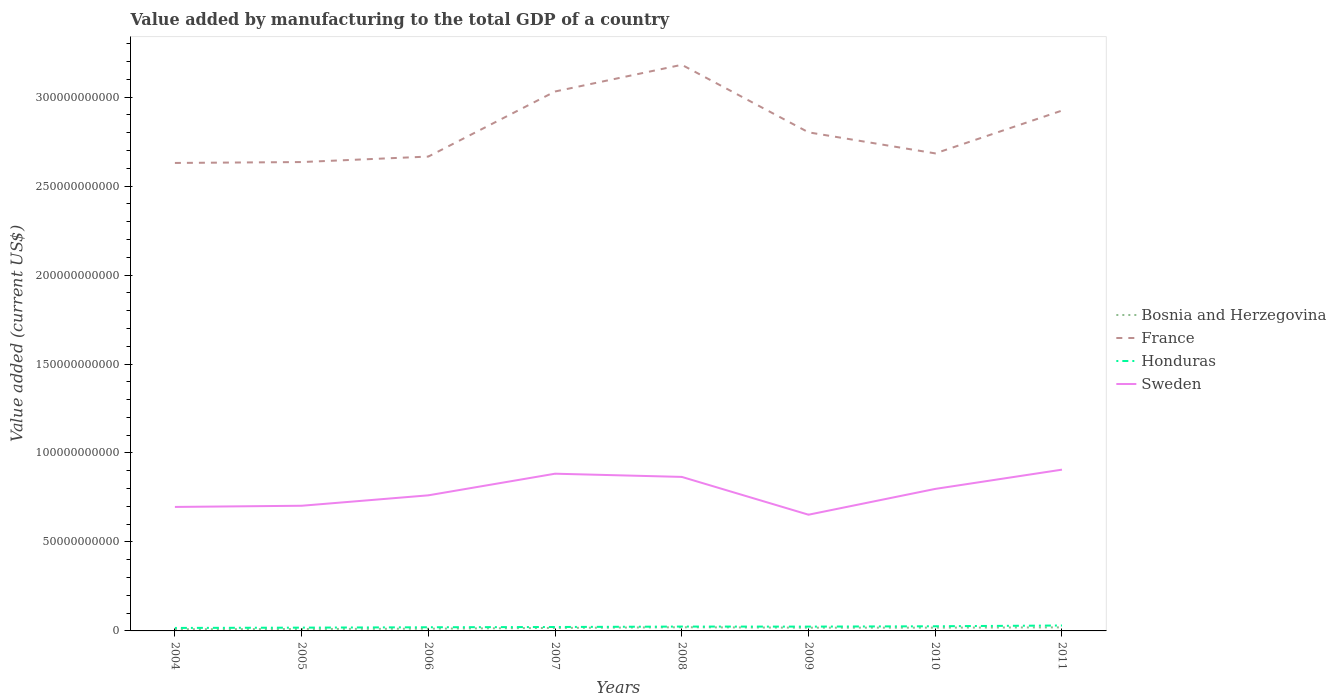How many different coloured lines are there?
Offer a terse response. 4. Does the line corresponding to Sweden intersect with the line corresponding to Honduras?
Your response must be concise. No. Across all years, what is the maximum value added by manufacturing to the total GDP in Honduras?
Make the answer very short. 1.68e+09. In which year was the value added by manufacturing to the total GDP in Honduras maximum?
Your answer should be very brief. 2004. What is the total value added by manufacturing to the total GDP in Bosnia and Herzegovina in the graph?
Provide a short and direct response. -1.40e+08. What is the difference between the highest and the second highest value added by manufacturing to the total GDP in Sweden?
Your answer should be compact. 2.53e+1. What is the difference between the highest and the lowest value added by manufacturing to the total GDP in Bosnia and Herzegovina?
Keep it short and to the point. 5. Is the value added by manufacturing to the total GDP in Bosnia and Herzegovina strictly greater than the value added by manufacturing to the total GDP in France over the years?
Make the answer very short. Yes. How many lines are there?
Make the answer very short. 4. How many years are there in the graph?
Offer a very short reply. 8. What is the difference between two consecutive major ticks on the Y-axis?
Your answer should be very brief. 5.00e+1. Does the graph contain any zero values?
Provide a succinct answer. No. Does the graph contain grids?
Your answer should be compact. No. Where does the legend appear in the graph?
Keep it short and to the point. Center right. How are the legend labels stacked?
Your answer should be compact. Vertical. What is the title of the graph?
Make the answer very short. Value added by manufacturing to the total GDP of a country. Does "Russian Federation" appear as one of the legend labels in the graph?
Offer a very short reply. No. What is the label or title of the Y-axis?
Provide a succinct answer. Value added (current US$). What is the Value added (current US$) of Bosnia and Herzegovina in 2004?
Make the answer very short. 9.40e+08. What is the Value added (current US$) of France in 2004?
Provide a succinct answer. 2.63e+11. What is the Value added (current US$) in Honduras in 2004?
Give a very brief answer. 1.68e+09. What is the Value added (current US$) of Sweden in 2004?
Offer a very short reply. 6.97e+1. What is the Value added (current US$) in Bosnia and Herzegovina in 2005?
Give a very brief answer. 1.08e+09. What is the Value added (current US$) in France in 2005?
Keep it short and to the point. 2.64e+11. What is the Value added (current US$) of Honduras in 2005?
Keep it short and to the point. 1.85e+09. What is the Value added (current US$) of Sweden in 2005?
Your answer should be very brief. 7.03e+1. What is the Value added (current US$) of Bosnia and Herzegovina in 2006?
Your response must be concise. 1.25e+09. What is the Value added (current US$) of France in 2006?
Ensure brevity in your answer.  2.67e+11. What is the Value added (current US$) of Honduras in 2006?
Provide a succinct answer. 2.06e+09. What is the Value added (current US$) of Sweden in 2006?
Your response must be concise. 7.62e+1. What is the Value added (current US$) in Bosnia and Herzegovina in 2007?
Keep it short and to the point. 1.68e+09. What is the Value added (current US$) of France in 2007?
Your response must be concise. 3.03e+11. What is the Value added (current US$) in Honduras in 2007?
Offer a very short reply. 2.20e+09. What is the Value added (current US$) of Sweden in 2007?
Give a very brief answer. 8.84e+1. What is the Value added (current US$) of Bosnia and Herzegovina in 2008?
Make the answer very short. 2.07e+09. What is the Value added (current US$) of France in 2008?
Make the answer very short. 3.18e+11. What is the Value added (current US$) of Honduras in 2008?
Make the answer very short. 2.46e+09. What is the Value added (current US$) in Sweden in 2008?
Offer a very short reply. 8.66e+1. What is the Value added (current US$) of Bosnia and Herzegovina in 2009?
Your answer should be very brief. 1.81e+09. What is the Value added (current US$) of France in 2009?
Offer a terse response. 2.80e+11. What is the Value added (current US$) in Honduras in 2009?
Offer a very short reply. 2.43e+09. What is the Value added (current US$) in Sweden in 2009?
Provide a succinct answer. 6.53e+1. What is the Value added (current US$) of Bosnia and Herzegovina in 2010?
Offer a very short reply. 1.83e+09. What is the Value added (current US$) in France in 2010?
Offer a very short reply. 2.68e+11. What is the Value added (current US$) in Honduras in 2010?
Provide a short and direct response. 2.62e+09. What is the Value added (current US$) of Sweden in 2010?
Keep it short and to the point. 7.98e+1. What is the Value added (current US$) in Bosnia and Herzegovina in 2011?
Your response must be concise. 2.00e+09. What is the Value added (current US$) of France in 2011?
Your answer should be very brief. 2.92e+11. What is the Value added (current US$) in Honduras in 2011?
Provide a succinct answer. 3.05e+09. What is the Value added (current US$) in Sweden in 2011?
Provide a succinct answer. 9.06e+1. Across all years, what is the maximum Value added (current US$) of Bosnia and Herzegovina?
Provide a short and direct response. 2.07e+09. Across all years, what is the maximum Value added (current US$) in France?
Keep it short and to the point. 3.18e+11. Across all years, what is the maximum Value added (current US$) in Honduras?
Give a very brief answer. 3.05e+09. Across all years, what is the maximum Value added (current US$) of Sweden?
Your answer should be compact. 9.06e+1. Across all years, what is the minimum Value added (current US$) of Bosnia and Herzegovina?
Keep it short and to the point. 9.40e+08. Across all years, what is the minimum Value added (current US$) in France?
Offer a very short reply. 2.63e+11. Across all years, what is the minimum Value added (current US$) of Honduras?
Offer a terse response. 1.68e+09. Across all years, what is the minimum Value added (current US$) of Sweden?
Provide a succinct answer. 6.53e+1. What is the total Value added (current US$) of Bosnia and Herzegovina in the graph?
Keep it short and to the point. 1.27e+1. What is the total Value added (current US$) in France in the graph?
Your answer should be very brief. 2.26e+12. What is the total Value added (current US$) of Honduras in the graph?
Keep it short and to the point. 1.83e+1. What is the total Value added (current US$) of Sweden in the graph?
Offer a terse response. 6.27e+11. What is the difference between the Value added (current US$) of Bosnia and Herzegovina in 2004 and that in 2005?
Your answer should be compact. -1.40e+08. What is the difference between the Value added (current US$) of France in 2004 and that in 2005?
Your response must be concise. -5.05e+08. What is the difference between the Value added (current US$) in Honduras in 2004 and that in 2005?
Ensure brevity in your answer.  -1.65e+08. What is the difference between the Value added (current US$) in Sweden in 2004 and that in 2005?
Make the answer very short. -6.65e+08. What is the difference between the Value added (current US$) of Bosnia and Herzegovina in 2004 and that in 2006?
Provide a succinct answer. -3.15e+08. What is the difference between the Value added (current US$) in France in 2004 and that in 2006?
Your response must be concise. -3.59e+09. What is the difference between the Value added (current US$) in Honduras in 2004 and that in 2006?
Provide a short and direct response. -3.76e+08. What is the difference between the Value added (current US$) of Sweden in 2004 and that in 2006?
Your response must be concise. -6.53e+09. What is the difference between the Value added (current US$) of Bosnia and Herzegovina in 2004 and that in 2007?
Ensure brevity in your answer.  -7.42e+08. What is the difference between the Value added (current US$) of France in 2004 and that in 2007?
Your answer should be very brief. -4.02e+1. What is the difference between the Value added (current US$) in Honduras in 2004 and that in 2007?
Provide a succinct answer. -5.23e+08. What is the difference between the Value added (current US$) in Sweden in 2004 and that in 2007?
Give a very brief answer. -1.87e+1. What is the difference between the Value added (current US$) in Bosnia and Herzegovina in 2004 and that in 2008?
Provide a succinct answer. -1.13e+09. What is the difference between the Value added (current US$) in France in 2004 and that in 2008?
Make the answer very short. -5.52e+1. What is the difference between the Value added (current US$) in Honduras in 2004 and that in 2008?
Your response must be concise. -7.75e+08. What is the difference between the Value added (current US$) of Sweden in 2004 and that in 2008?
Provide a succinct answer. -1.69e+1. What is the difference between the Value added (current US$) of Bosnia and Herzegovina in 2004 and that in 2009?
Ensure brevity in your answer.  -8.75e+08. What is the difference between the Value added (current US$) in France in 2004 and that in 2009?
Keep it short and to the point. -1.72e+1. What is the difference between the Value added (current US$) of Honduras in 2004 and that in 2009?
Offer a very short reply. -7.45e+08. What is the difference between the Value added (current US$) of Sweden in 2004 and that in 2009?
Provide a succinct answer. 4.37e+09. What is the difference between the Value added (current US$) in Bosnia and Herzegovina in 2004 and that in 2010?
Provide a succinct answer. -8.93e+08. What is the difference between the Value added (current US$) of France in 2004 and that in 2010?
Offer a very short reply. -5.37e+09. What is the difference between the Value added (current US$) of Honduras in 2004 and that in 2010?
Provide a short and direct response. -9.39e+08. What is the difference between the Value added (current US$) of Sweden in 2004 and that in 2010?
Keep it short and to the point. -1.01e+1. What is the difference between the Value added (current US$) in Bosnia and Herzegovina in 2004 and that in 2011?
Your answer should be compact. -1.06e+09. What is the difference between the Value added (current US$) in France in 2004 and that in 2011?
Offer a very short reply. -2.94e+1. What is the difference between the Value added (current US$) of Honduras in 2004 and that in 2011?
Your answer should be very brief. -1.36e+09. What is the difference between the Value added (current US$) of Sweden in 2004 and that in 2011?
Offer a terse response. -2.10e+1. What is the difference between the Value added (current US$) of Bosnia and Herzegovina in 2005 and that in 2006?
Your answer should be very brief. -1.75e+08. What is the difference between the Value added (current US$) in France in 2005 and that in 2006?
Ensure brevity in your answer.  -3.08e+09. What is the difference between the Value added (current US$) of Honduras in 2005 and that in 2006?
Keep it short and to the point. -2.11e+08. What is the difference between the Value added (current US$) of Sweden in 2005 and that in 2006?
Ensure brevity in your answer.  -5.86e+09. What is the difference between the Value added (current US$) of Bosnia and Herzegovina in 2005 and that in 2007?
Provide a short and direct response. -6.03e+08. What is the difference between the Value added (current US$) of France in 2005 and that in 2007?
Ensure brevity in your answer.  -3.97e+1. What is the difference between the Value added (current US$) of Honduras in 2005 and that in 2007?
Provide a short and direct response. -3.58e+08. What is the difference between the Value added (current US$) in Sweden in 2005 and that in 2007?
Make the answer very short. -1.80e+1. What is the difference between the Value added (current US$) of Bosnia and Herzegovina in 2005 and that in 2008?
Make the answer very short. -9.92e+08. What is the difference between the Value added (current US$) in France in 2005 and that in 2008?
Your answer should be compact. -5.47e+1. What is the difference between the Value added (current US$) in Honduras in 2005 and that in 2008?
Provide a succinct answer. -6.09e+08. What is the difference between the Value added (current US$) of Sweden in 2005 and that in 2008?
Provide a succinct answer. -1.62e+1. What is the difference between the Value added (current US$) in Bosnia and Herzegovina in 2005 and that in 2009?
Offer a very short reply. -7.35e+08. What is the difference between the Value added (current US$) in France in 2005 and that in 2009?
Provide a short and direct response. -1.67e+1. What is the difference between the Value added (current US$) in Honduras in 2005 and that in 2009?
Keep it short and to the point. -5.80e+08. What is the difference between the Value added (current US$) of Sweden in 2005 and that in 2009?
Make the answer very short. 5.03e+09. What is the difference between the Value added (current US$) of Bosnia and Herzegovina in 2005 and that in 2010?
Offer a very short reply. -7.53e+08. What is the difference between the Value added (current US$) in France in 2005 and that in 2010?
Offer a terse response. -4.87e+09. What is the difference between the Value added (current US$) of Honduras in 2005 and that in 2010?
Keep it short and to the point. -7.73e+08. What is the difference between the Value added (current US$) of Sweden in 2005 and that in 2010?
Provide a short and direct response. -9.47e+09. What is the difference between the Value added (current US$) in Bosnia and Herzegovina in 2005 and that in 2011?
Make the answer very short. -9.18e+08. What is the difference between the Value added (current US$) of France in 2005 and that in 2011?
Give a very brief answer. -2.89e+1. What is the difference between the Value added (current US$) of Honduras in 2005 and that in 2011?
Offer a very short reply. -1.20e+09. What is the difference between the Value added (current US$) in Sweden in 2005 and that in 2011?
Give a very brief answer. -2.03e+1. What is the difference between the Value added (current US$) in Bosnia and Herzegovina in 2006 and that in 2007?
Ensure brevity in your answer.  -4.27e+08. What is the difference between the Value added (current US$) of France in 2006 and that in 2007?
Keep it short and to the point. -3.66e+1. What is the difference between the Value added (current US$) of Honduras in 2006 and that in 2007?
Provide a short and direct response. -1.47e+08. What is the difference between the Value added (current US$) in Sweden in 2006 and that in 2007?
Give a very brief answer. -1.22e+1. What is the difference between the Value added (current US$) of Bosnia and Herzegovina in 2006 and that in 2008?
Give a very brief answer. -8.16e+08. What is the difference between the Value added (current US$) in France in 2006 and that in 2008?
Provide a succinct answer. -5.16e+1. What is the difference between the Value added (current US$) in Honduras in 2006 and that in 2008?
Your answer should be compact. -3.99e+08. What is the difference between the Value added (current US$) of Sweden in 2006 and that in 2008?
Provide a short and direct response. -1.04e+1. What is the difference between the Value added (current US$) in Bosnia and Herzegovina in 2006 and that in 2009?
Offer a terse response. -5.60e+08. What is the difference between the Value added (current US$) in France in 2006 and that in 2009?
Make the answer very short. -1.36e+1. What is the difference between the Value added (current US$) in Honduras in 2006 and that in 2009?
Your response must be concise. -3.69e+08. What is the difference between the Value added (current US$) of Sweden in 2006 and that in 2009?
Provide a short and direct response. 1.09e+1. What is the difference between the Value added (current US$) of Bosnia and Herzegovina in 2006 and that in 2010?
Offer a very short reply. -5.78e+08. What is the difference between the Value added (current US$) in France in 2006 and that in 2010?
Give a very brief answer. -1.79e+09. What is the difference between the Value added (current US$) of Honduras in 2006 and that in 2010?
Your response must be concise. -5.63e+08. What is the difference between the Value added (current US$) of Sweden in 2006 and that in 2010?
Offer a very short reply. -3.61e+09. What is the difference between the Value added (current US$) of Bosnia and Herzegovina in 2006 and that in 2011?
Keep it short and to the point. -7.43e+08. What is the difference between the Value added (current US$) in France in 2006 and that in 2011?
Your response must be concise. -2.59e+1. What is the difference between the Value added (current US$) of Honduras in 2006 and that in 2011?
Your answer should be compact. -9.88e+08. What is the difference between the Value added (current US$) in Sweden in 2006 and that in 2011?
Ensure brevity in your answer.  -1.44e+1. What is the difference between the Value added (current US$) of Bosnia and Herzegovina in 2007 and that in 2008?
Offer a very short reply. -3.89e+08. What is the difference between the Value added (current US$) in France in 2007 and that in 2008?
Provide a short and direct response. -1.50e+1. What is the difference between the Value added (current US$) in Honduras in 2007 and that in 2008?
Ensure brevity in your answer.  -2.52e+08. What is the difference between the Value added (current US$) in Sweden in 2007 and that in 2008?
Provide a succinct answer. 1.80e+09. What is the difference between the Value added (current US$) of Bosnia and Herzegovina in 2007 and that in 2009?
Keep it short and to the point. -1.33e+08. What is the difference between the Value added (current US$) of France in 2007 and that in 2009?
Provide a short and direct response. 2.30e+1. What is the difference between the Value added (current US$) of Honduras in 2007 and that in 2009?
Make the answer very short. -2.22e+08. What is the difference between the Value added (current US$) of Sweden in 2007 and that in 2009?
Give a very brief answer. 2.30e+1. What is the difference between the Value added (current US$) of Bosnia and Herzegovina in 2007 and that in 2010?
Make the answer very short. -1.50e+08. What is the difference between the Value added (current US$) in France in 2007 and that in 2010?
Your answer should be very brief. 3.48e+1. What is the difference between the Value added (current US$) of Honduras in 2007 and that in 2010?
Give a very brief answer. -4.16e+08. What is the difference between the Value added (current US$) of Sweden in 2007 and that in 2010?
Your response must be concise. 8.54e+09. What is the difference between the Value added (current US$) in Bosnia and Herzegovina in 2007 and that in 2011?
Make the answer very short. -3.15e+08. What is the difference between the Value added (current US$) of France in 2007 and that in 2011?
Your answer should be compact. 1.07e+1. What is the difference between the Value added (current US$) in Honduras in 2007 and that in 2011?
Provide a succinct answer. -8.42e+08. What is the difference between the Value added (current US$) of Sweden in 2007 and that in 2011?
Offer a very short reply. -2.28e+09. What is the difference between the Value added (current US$) of Bosnia and Herzegovina in 2008 and that in 2009?
Your answer should be compact. 2.56e+08. What is the difference between the Value added (current US$) in France in 2008 and that in 2009?
Your answer should be compact. 3.80e+1. What is the difference between the Value added (current US$) in Honduras in 2008 and that in 2009?
Provide a short and direct response. 2.93e+07. What is the difference between the Value added (current US$) of Sweden in 2008 and that in 2009?
Your response must be concise. 2.12e+1. What is the difference between the Value added (current US$) of Bosnia and Herzegovina in 2008 and that in 2010?
Give a very brief answer. 2.39e+08. What is the difference between the Value added (current US$) of France in 2008 and that in 2010?
Make the answer very short. 4.98e+1. What is the difference between the Value added (current US$) of Honduras in 2008 and that in 2010?
Give a very brief answer. -1.64e+08. What is the difference between the Value added (current US$) of Sweden in 2008 and that in 2010?
Your answer should be very brief. 6.74e+09. What is the difference between the Value added (current US$) in Bosnia and Herzegovina in 2008 and that in 2011?
Your response must be concise. 7.37e+07. What is the difference between the Value added (current US$) of France in 2008 and that in 2011?
Provide a short and direct response. 2.57e+1. What is the difference between the Value added (current US$) in Honduras in 2008 and that in 2011?
Provide a succinct answer. -5.90e+08. What is the difference between the Value added (current US$) of Sweden in 2008 and that in 2011?
Give a very brief answer. -4.08e+09. What is the difference between the Value added (current US$) in Bosnia and Herzegovina in 2009 and that in 2010?
Ensure brevity in your answer.  -1.75e+07. What is the difference between the Value added (current US$) of France in 2009 and that in 2010?
Provide a succinct answer. 1.18e+1. What is the difference between the Value added (current US$) of Honduras in 2009 and that in 2010?
Offer a very short reply. -1.93e+08. What is the difference between the Value added (current US$) of Sweden in 2009 and that in 2010?
Your answer should be very brief. -1.45e+1. What is the difference between the Value added (current US$) of Bosnia and Herzegovina in 2009 and that in 2011?
Your answer should be compact. -1.83e+08. What is the difference between the Value added (current US$) of France in 2009 and that in 2011?
Provide a short and direct response. -1.22e+1. What is the difference between the Value added (current US$) in Honduras in 2009 and that in 2011?
Provide a short and direct response. -6.19e+08. What is the difference between the Value added (current US$) of Sweden in 2009 and that in 2011?
Offer a very short reply. -2.53e+1. What is the difference between the Value added (current US$) in Bosnia and Herzegovina in 2010 and that in 2011?
Provide a short and direct response. -1.65e+08. What is the difference between the Value added (current US$) in France in 2010 and that in 2011?
Offer a terse response. -2.41e+1. What is the difference between the Value added (current US$) of Honduras in 2010 and that in 2011?
Offer a very short reply. -4.26e+08. What is the difference between the Value added (current US$) of Sweden in 2010 and that in 2011?
Your response must be concise. -1.08e+1. What is the difference between the Value added (current US$) of Bosnia and Herzegovina in 2004 and the Value added (current US$) of France in 2005?
Give a very brief answer. -2.63e+11. What is the difference between the Value added (current US$) of Bosnia and Herzegovina in 2004 and the Value added (current US$) of Honduras in 2005?
Offer a terse response. -9.06e+08. What is the difference between the Value added (current US$) of Bosnia and Herzegovina in 2004 and the Value added (current US$) of Sweden in 2005?
Your response must be concise. -6.94e+1. What is the difference between the Value added (current US$) of France in 2004 and the Value added (current US$) of Honduras in 2005?
Ensure brevity in your answer.  2.61e+11. What is the difference between the Value added (current US$) in France in 2004 and the Value added (current US$) in Sweden in 2005?
Give a very brief answer. 1.93e+11. What is the difference between the Value added (current US$) in Honduras in 2004 and the Value added (current US$) in Sweden in 2005?
Provide a succinct answer. -6.87e+1. What is the difference between the Value added (current US$) in Bosnia and Herzegovina in 2004 and the Value added (current US$) in France in 2006?
Give a very brief answer. -2.66e+11. What is the difference between the Value added (current US$) of Bosnia and Herzegovina in 2004 and the Value added (current US$) of Honduras in 2006?
Ensure brevity in your answer.  -1.12e+09. What is the difference between the Value added (current US$) in Bosnia and Herzegovina in 2004 and the Value added (current US$) in Sweden in 2006?
Your answer should be very brief. -7.53e+1. What is the difference between the Value added (current US$) of France in 2004 and the Value added (current US$) of Honduras in 2006?
Offer a very short reply. 2.61e+11. What is the difference between the Value added (current US$) of France in 2004 and the Value added (current US$) of Sweden in 2006?
Give a very brief answer. 1.87e+11. What is the difference between the Value added (current US$) of Honduras in 2004 and the Value added (current US$) of Sweden in 2006?
Your response must be concise. -7.45e+1. What is the difference between the Value added (current US$) in Bosnia and Herzegovina in 2004 and the Value added (current US$) in France in 2007?
Give a very brief answer. -3.02e+11. What is the difference between the Value added (current US$) of Bosnia and Herzegovina in 2004 and the Value added (current US$) of Honduras in 2007?
Provide a short and direct response. -1.26e+09. What is the difference between the Value added (current US$) of Bosnia and Herzegovina in 2004 and the Value added (current US$) of Sweden in 2007?
Your answer should be very brief. -8.74e+1. What is the difference between the Value added (current US$) of France in 2004 and the Value added (current US$) of Honduras in 2007?
Your response must be concise. 2.61e+11. What is the difference between the Value added (current US$) of France in 2004 and the Value added (current US$) of Sweden in 2007?
Offer a very short reply. 1.75e+11. What is the difference between the Value added (current US$) of Honduras in 2004 and the Value added (current US$) of Sweden in 2007?
Give a very brief answer. -8.67e+1. What is the difference between the Value added (current US$) in Bosnia and Herzegovina in 2004 and the Value added (current US$) in France in 2008?
Keep it short and to the point. -3.17e+11. What is the difference between the Value added (current US$) of Bosnia and Herzegovina in 2004 and the Value added (current US$) of Honduras in 2008?
Make the answer very short. -1.52e+09. What is the difference between the Value added (current US$) of Bosnia and Herzegovina in 2004 and the Value added (current US$) of Sweden in 2008?
Offer a terse response. -8.56e+1. What is the difference between the Value added (current US$) of France in 2004 and the Value added (current US$) of Honduras in 2008?
Keep it short and to the point. 2.61e+11. What is the difference between the Value added (current US$) in France in 2004 and the Value added (current US$) in Sweden in 2008?
Give a very brief answer. 1.76e+11. What is the difference between the Value added (current US$) of Honduras in 2004 and the Value added (current US$) of Sweden in 2008?
Provide a succinct answer. -8.49e+1. What is the difference between the Value added (current US$) in Bosnia and Herzegovina in 2004 and the Value added (current US$) in France in 2009?
Ensure brevity in your answer.  -2.79e+11. What is the difference between the Value added (current US$) in Bosnia and Herzegovina in 2004 and the Value added (current US$) in Honduras in 2009?
Provide a short and direct response. -1.49e+09. What is the difference between the Value added (current US$) of Bosnia and Herzegovina in 2004 and the Value added (current US$) of Sweden in 2009?
Your response must be concise. -6.44e+1. What is the difference between the Value added (current US$) in France in 2004 and the Value added (current US$) in Honduras in 2009?
Your answer should be compact. 2.61e+11. What is the difference between the Value added (current US$) in France in 2004 and the Value added (current US$) in Sweden in 2009?
Provide a short and direct response. 1.98e+11. What is the difference between the Value added (current US$) in Honduras in 2004 and the Value added (current US$) in Sweden in 2009?
Your response must be concise. -6.36e+1. What is the difference between the Value added (current US$) of Bosnia and Herzegovina in 2004 and the Value added (current US$) of France in 2010?
Your answer should be compact. -2.67e+11. What is the difference between the Value added (current US$) of Bosnia and Herzegovina in 2004 and the Value added (current US$) of Honduras in 2010?
Ensure brevity in your answer.  -1.68e+09. What is the difference between the Value added (current US$) in Bosnia and Herzegovina in 2004 and the Value added (current US$) in Sweden in 2010?
Offer a terse response. -7.89e+1. What is the difference between the Value added (current US$) in France in 2004 and the Value added (current US$) in Honduras in 2010?
Your answer should be compact. 2.60e+11. What is the difference between the Value added (current US$) in France in 2004 and the Value added (current US$) in Sweden in 2010?
Make the answer very short. 1.83e+11. What is the difference between the Value added (current US$) in Honduras in 2004 and the Value added (current US$) in Sweden in 2010?
Your answer should be very brief. -7.81e+1. What is the difference between the Value added (current US$) in Bosnia and Herzegovina in 2004 and the Value added (current US$) in France in 2011?
Keep it short and to the point. -2.91e+11. What is the difference between the Value added (current US$) of Bosnia and Herzegovina in 2004 and the Value added (current US$) of Honduras in 2011?
Provide a short and direct response. -2.11e+09. What is the difference between the Value added (current US$) in Bosnia and Herzegovina in 2004 and the Value added (current US$) in Sweden in 2011?
Provide a succinct answer. -8.97e+1. What is the difference between the Value added (current US$) in France in 2004 and the Value added (current US$) in Honduras in 2011?
Your answer should be very brief. 2.60e+11. What is the difference between the Value added (current US$) in France in 2004 and the Value added (current US$) in Sweden in 2011?
Provide a short and direct response. 1.72e+11. What is the difference between the Value added (current US$) in Honduras in 2004 and the Value added (current US$) in Sweden in 2011?
Your answer should be compact. -8.90e+1. What is the difference between the Value added (current US$) of Bosnia and Herzegovina in 2005 and the Value added (current US$) of France in 2006?
Your answer should be compact. -2.66e+11. What is the difference between the Value added (current US$) of Bosnia and Herzegovina in 2005 and the Value added (current US$) of Honduras in 2006?
Keep it short and to the point. -9.77e+08. What is the difference between the Value added (current US$) of Bosnia and Herzegovina in 2005 and the Value added (current US$) of Sweden in 2006?
Offer a very short reply. -7.51e+1. What is the difference between the Value added (current US$) of France in 2005 and the Value added (current US$) of Honduras in 2006?
Your answer should be compact. 2.61e+11. What is the difference between the Value added (current US$) in France in 2005 and the Value added (current US$) in Sweden in 2006?
Ensure brevity in your answer.  1.87e+11. What is the difference between the Value added (current US$) of Honduras in 2005 and the Value added (current US$) of Sweden in 2006?
Keep it short and to the point. -7.44e+1. What is the difference between the Value added (current US$) in Bosnia and Herzegovina in 2005 and the Value added (current US$) in France in 2007?
Keep it short and to the point. -3.02e+11. What is the difference between the Value added (current US$) in Bosnia and Herzegovina in 2005 and the Value added (current US$) in Honduras in 2007?
Make the answer very short. -1.12e+09. What is the difference between the Value added (current US$) in Bosnia and Herzegovina in 2005 and the Value added (current US$) in Sweden in 2007?
Your response must be concise. -8.73e+1. What is the difference between the Value added (current US$) in France in 2005 and the Value added (current US$) in Honduras in 2007?
Your answer should be very brief. 2.61e+11. What is the difference between the Value added (current US$) of France in 2005 and the Value added (current US$) of Sweden in 2007?
Your answer should be very brief. 1.75e+11. What is the difference between the Value added (current US$) of Honduras in 2005 and the Value added (current US$) of Sweden in 2007?
Your answer should be compact. -8.65e+1. What is the difference between the Value added (current US$) of Bosnia and Herzegovina in 2005 and the Value added (current US$) of France in 2008?
Give a very brief answer. -3.17e+11. What is the difference between the Value added (current US$) of Bosnia and Herzegovina in 2005 and the Value added (current US$) of Honduras in 2008?
Offer a terse response. -1.38e+09. What is the difference between the Value added (current US$) in Bosnia and Herzegovina in 2005 and the Value added (current US$) in Sweden in 2008?
Provide a short and direct response. -8.55e+1. What is the difference between the Value added (current US$) of France in 2005 and the Value added (current US$) of Honduras in 2008?
Provide a short and direct response. 2.61e+11. What is the difference between the Value added (current US$) of France in 2005 and the Value added (current US$) of Sweden in 2008?
Your answer should be compact. 1.77e+11. What is the difference between the Value added (current US$) of Honduras in 2005 and the Value added (current US$) of Sweden in 2008?
Provide a succinct answer. -8.47e+1. What is the difference between the Value added (current US$) in Bosnia and Herzegovina in 2005 and the Value added (current US$) in France in 2009?
Provide a short and direct response. -2.79e+11. What is the difference between the Value added (current US$) in Bosnia and Herzegovina in 2005 and the Value added (current US$) in Honduras in 2009?
Provide a succinct answer. -1.35e+09. What is the difference between the Value added (current US$) in Bosnia and Herzegovina in 2005 and the Value added (current US$) in Sweden in 2009?
Give a very brief answer. -6.42e+1. What is the difference between the Value added (current US$) in France in 2005 and the Value added (current US$) in Honduras in 2009?
Provide a short and direct response. 2.61e+11. What is the difference between the Value added (current US$) in France in 2005 and the Value added (current US$) in Sweden in 2009?
Your response must be concise. 1.98e+11. What is the difference between the Value added (current US$) in Honduras in 2005 and the Value added (current US$) in Sweden in 2009?
Your response must be concise. -6.35e+1. What is the difference between the Value added (current US$) of Bosnia and Herzegovina in 2005 and the Value added (current US$) of France in 2010?
Your answer should be compact. -2.67e+11. What is the difference between the Value added (current US$) in Bosnia and Herzegovina in 2005 and the Value added (current US$) in Honduras in 2010?
Your answer should be compact. -1.54e+09. What is the difference between the Value added (current US$) of Bosnia and Herzegovina in 2005 and the Value added (current US$) of Sweden in 2010?
Provide a short and direct response. -7.87e+1. What is the difference between the Value added (current US$) of France in 2005 and the Value added (current US$) of Honduras in 2010?
Make the answer very short. 2.61e+11. What is the difference between the Value added (current US$) of France in 2005 and the Value added (current US$) of Sweden in 2010?
Make the answer very short. 1.84e+11. What is the difference between the Value added (current US$) of Honduras in 2005 and the Value added (current US$) of Sweden in 2010?
Your answer should be very brief. -7.80e+1. What is the difference between the Value added (current US$) in Bosnia and Herzegovina in 2005 and the Value added (current US$) in France in 2011?
Offer a very short reply. -2.91e+11. What is the difference between the Value added (current US$) in Bosnia and Herzegovina in 2005 and the Value added (current US$) in Honduras in 2011?
Your answer should be compact. -1.97e+09. What is the difference between the Value added (current US$) of Bosnia and Herzegovina in 2005 and the Value added (current US$) of Sweden in 2011?
Your response must be concise. -8.96e+1. What is the difference between the Value added (current US$) of France in 2005 and the Value added (current US$) of Honduras in 2011?
Keep it short and to the point. 2.60e+11. What is the difference between the Value added (current US$) in France in 2005 and the Value added (current US$) in Sweden in 2011?
Ensure brevity in your answer.  1.73e+11. What is the difference between the Value added (current US$) in Honduras in 2005 and the Value added (current US$) in Sweden in 2011?
Your answer should be very brief. -8.88e+1. What is the difference between the Value added (current US$) in Bosnia and Herzegovina in 2006 and the Value added (current US$) in France in 2007?
Make the answer very short. -3.02e+11. What is the difference between the Value added (current US$) of Bosnia and Herzegovina in 2006 and the Value added (current US$) of Honduras in 2007?
Your response must be concise. -9.49e+08. What is the difference between the Value added (current US$) of Bosnia and Herzegovina in 2006 and the Value added (current US$) of Sweden in 2007?
Ensure brevity in your answer.  -8.71e+1. What is the difference between the Value added (current US$) of France in 2006 and the Value added (current US$) of Honduras in 2007?
Make the answer very short. 2.64e+11. What is the difference between the Value added (current US$) of France in 2006 and the Value added (current US$) of Sweden in 2007?
Your response must be concise. 1.78e+11. What is the difference between the Value added (current US$) of Honduras in 2006 and the Value added (current US$) of Sweden in 2007?
Offer a terse response. -8.63e+1. What is the difference between the Value added (current US$) of Bosnia and Herzegovina in 2006 and the Value added (current US$) of France in 2008?
Your answer should be compact. -3.17e+11. What is the difference between the Value added (current US$) of Bosnia and Herzegovina in 2006 and the Value added (current US$) of Honduras in 2008?
Your answer should be compact. -1.20e+09. What is the difference between the Value added (current US$) in Bosnia and Herzegovina in 2006 and the Value added (current US$) in Sweden in 2008?
Your answer should be very brief. -8.53e+1. What is the difference between the Value added (current US$) of France in 2006 and the Value added (current US$) of Honduras in 2008?
Your answer should be compact. 2.64e+11. What is the difference between the Value added (current US$) in France in 2006 and the Value added (current US$) in Sweden in 2008?
Ensure brevity in your answer.  1.80e+11. What is the difference between the Value added (current US$) in Honduras in 2006 and the Value added (current US$) in Sweden in 2008?
Your answer should be very brief. -8.45e+1. What is the difference between the Value added (current US$) in Bosnia and Herzegovina in 2006 and the Value added (current US$) in France in 2009?
Keep it short and to the point. -2.79e+11. What is the difference between the Value added (current US$) of Bosnia and Herzegovina in 2006 and the Value added (current US$) of Honduras in 2009?
Your answer should be very brief. -1.17e+09. What is the difference between the Value added (current US$) of Bosnia and Herzegovina in 2006 and the Value added (current US$) of Sweden in 2009?
Give a very brief answer. -6.41e+1. What is the difference between the Value added (current US$) in France in 2006 and the Value added (current US$) in Honduras in 2009?
Offer a terse response. 2.64e+11. What is the difference between the Value added (current US$) of France in 2006 and the Value added (current US$) of Sweden in 2009?
Provide a short and direct response. 2.01e+11. What is the difference between the Value added (current US$) in Honduras in 2006 and the Value added (current US$) in Sweden in 2009?
Offer a terse response. -6.33e+1. What is the difference between the Value added (current US$) in Bosnia and Herzegovina in 2006 and the Value added (current US$) in France in 2010?
Provide a succinct answer. -2.67e+11. What is the difference between the Value added (current US$) in Bosnia and Herzegovina in 2006 and the Value added (current US$) in Honduras in 2010?
Make the answer very short. -1.36e+09. What is the difference between the Value added (current US$) in Bosnia and Herzegovina in 2006 and the Value added (current US$) in Sweden in 2010?
Your answer should be very brief. -7.86e+1. What is the difference between the Value added (current US$) in France in 2006 and the Value added (current US$) in Honduras in 2010?
Your response must be concise. 2.64e+11. What is the difference between the Value added (current US$) in France in 2006 and the Value added (current US$) in Sweden in 2010?
Keep it short and to the point. 1.87e+11. What is the difference between the Value added (current US$) in Honduras in 2006 and the Value added (current US$) in Sweden in 2010?
Offer a very short reply. -7.78e+1. What is the difference between the Value added (current US$) in Bosnia and Herzegovina in 2006 and the Value added (current US$) in France in 2011?
Give a very brief answer. -2.91e+11. What is the difference between the Value added (current US$) of Bosnia and Herzegovina in 2006 and the Value added (current US$) of Honduras in 2011?
Your answer should be compact. -1.79e+09. What is the difference between the Value added (current US$) of Bosnia and Herzegovina in 2006 and the Value added (current US$) of Sweden in 2011?
Offer a very short reply. -8.94e+1. What is the difference between the Value added (current US$) in France in 2006 and the Value added (current US$) in Honduras in 2011?
Ensure brevity in your answer.  2.64e+11. What is the difference between the Value added (current US$) of France in 2006 and the Value added (current US$) of Sweden in 2011?
Provide a short and direct response. 1.76e+11. What is the difference between the Value added (current US$) in Honduras in 2006 and the Value added (current US$) in Sweden in 2011?
Offer a very short reply. -8.86e+1. What is the difference between the Value added (current US$) in Bosnia and Herzegovina in 2007 and the Value added (current US$) in France in 2008?
Make the answer very short. -3.16e+11. What is the difference between the Value added (current US$) in Bosnia and Herzegovina in 2007 and the Value added (current US$) in Honduras in 2008?
Offer a very short reply. -7.73e+08. What is the difference between the Value added (current US$) in Bosnia and Herzegovina in 2007 and the Value added (current US$) in Sweden in 2008?
Ensure brevity in your answer.  -8.49e+1. What is the difference between the Value added (current US$) in France in 2007 and the Value added (current US$) in Honduras in 2008?
Keep it short and to the point. 3.01e+11. What is the difference between the Value added (current US$) of France in 2007 and the Value added (current US$) of Sweden in 2008?
Your answer should be very brief. 2.17e+11. What is the difference between the Value added (current US$) in Honduras in 2007 and the Value added (current US$) in Sweden in 2008?
Your response must be concise. -8.44e+1. What is the difference between the Value added (current US$) of Bosnia and Herzegovina in 2007 and the Value added (current US$) of France in 2009?
Provide a short and direct response. -2.79e+11. What is the difference between the Value added (current US$) in Bosnia and Herzegovina in 2007 and the Value added (current US$) in Honduras in 2009?
Provide a short and direct response. -7.44e+08. What is the difference between the Value added (current US$) of Bosnia and Herzegovina in 2007 and the Value added (current US$) of Sweden in 2009?
Ensure brevity in your answer.  -6.36e+1. What is the difference between the Value added (current US$) of France in 2007 and the Value added (current US$) of Honduras in 2009?
Your answer should be compact. 3.01e+11. What is the difference between the Value added (current US$) in France in 2007 and the Value added (current US$) in Sweden in 2009?
Your answer should be very brief. 2.38e+11. What is the difference between the Value added (current US$) in Honduras in 2007 and the Value added (current US$) in Sweden in 2009?
Your response must be concise. -6.31e+1. What is the difference between the Value added (current US$) of Bosnia and Herzegovina in 2007 and the Value added (current US$) of France in 2010?
Your answer should be very brief. -2.67e+11. What is the difference between the Value added (current US$) in Bosnia and Herzegovina in 2007 and the Value added (current US$) in Honduras in 2010?
Make the answer very short. -9.37e+08. What is the difference between the Value added (current US$) in Bosnia and Herzegovina in 2007 and the Value added (current US$) in Sweden in 2010?
Provide a succinct answer. -7.81e+1. What is the difference between the Value added (current US$) of France in 2007 and the Value added (current US$) of Honduras in 2010?
Provide a succinct answer. 3.01e+11. What is the difference between the Value added (current US$) of France in 2007 and the Value added (current US$) of Sweden in 2010?
Provide a succinct answer. 2.23e+11. What is the difference between the Value added (current US$) in Honduras in 2007 and the Value added (current US$) in Sweden in 2010?
Offer a terse response. -7.76e+1. What is the difference between the Value added (current US$) of Bosnia and Herzegovina in 2007 and the Value added (current US$) of France in 2011?
Provide a succinct answer. -2.91e+11. What is the difference between the Value added (current US$) of Bosnia and Herzegovina in 2007 and the Value added (current US$) of Honduras in 2011?
Offer a terse response. -1.36e+09. What is the difference between the Value added (current US$) of Bosnia and Herzegovina in 2007 and the Value added (current US$) of Sweden in 2011?
Provide a succinct answer. -8.90e+1. What is the difference between the Value added (current US$) in France in 2007 and the Value added (current US$) in Honduras in 2011?
Give a very brief answer. 3.00e+11. What is the difference between the Value added (current US$) in France in 2007 and the Value added (current US$) in Sweden in 2011?
Your answer should be very brief. 2.13e+11. What is the difference between the Value added (current US$) in Honduras in 2007 and the Value added (current US$) in Sweden in 2011?
Your answer should be compact. -8.84e+1. What is the difference between the Value added (current US$) in Bosnia and Herzegovina in 2008 and the Value added (current US$) in France in 2009?
Give a very brief answer. -2.78e+11. What is the difference between the Value added (current US$) of Bosnia and Herzegovina in 2008 and the Value added (current US$) of Honduras in 2009?
Your answer should be very brief. -3.55e+08. What is the difference between the Value added (current US$) of Bosnia and Herzegovina in 2008 and the Value added (current US$) of Sweden in 2009?
Offer a very short reply. -6.32e+1. What is the difference between the Value added (current US$) in France in 2008 and the Value added (current US$) in Honduras in 2009?
Your answer should be very brief. 3.16e+11. What is the difference between the Value added (current US$) of France in 2008 and the Value added (current US$) of Sweden in 2009?
Provide a succinct answer. 2.53e+11. What is the difference between the Value added (current US$) in Honduras in 2008 and the Value added (current US$) in Sweden in 2009?
Make the answer very short. -6.29e+1. What is the difference between the Value added (current US$) of Bosnia and Herzegovina in 2008 and the Value added (current US$) of France in 2010?
Your answer should be compact. -2.66e+11. What is the difference between the Value added (current US$) of Bosnia and Herzegovina in 2008 and the Value added (current US$) of Honduras in 2010?
Keep it short and to the point. -5.48e+08. What is the difference between the Value added (current US$) of Bosnia and Herzegovina in 2008 and the Value added (current US$) of Sweden in 2010?
Your answer should be compact. -7.77e+1. What is the difference between the Value added (current US$) in France in 2008 and the Value added (current US$) in Honduras in 2010?
Provide a short and direct response. 3.16e+11. What is the difference between the Value added (current US$) of France in 2008 and the Value added (current US$) of Sweden in 2010?
Ensure brevity in your answer.  2.38e+11. What is the difference between the Value added (current US$) of Honduras in 2008 and the Value added (current US$) of Sweden in 2010?
Make the answer very short. -7.74e+1. What is the difference between the Value added (current US$) of Bosnia and Herzegovina in 2008 and the Value added (current US$) of France in 2011?
Keep it short and to the point. -2.90e+11. What is the difference between the Value added (current US$) of Bosnia and Herzegovina in 2008 and the Value added (current US$) of Honduras in 2011?
Make the answer very short. -9.74e+08. What is the difference between the Value added (current US$) of Bosnia and Herzegovina in 2008 and the Value added (current US$) of Sweden in 2011?
Offer a very short reply. -8.86e+1. What is the difference between the Value added (current US$) of France in 2008 and the Value added (current US$) of Honduras in 2011?
Provide a short and direct response. 3.15e+11. What is the difference between the Value added (current US$) of France in 2008 and the Value added (current US$) of Sweden in 2011?
Make the answer very short. 2.28e+11. What is the difference between the Value added (current US$) of Honduras in 2008 and the Value added (current US$) of Sweden in 2011?
Offer a very short reply. -8.82e+1. What is the difference between the Value added (current US$) of Bosnia and Herzegovina in 2009 and the Value added (current US$) of France in 2010?
Provide a succinct answer. -2.67e+11. What is the difference between the Value added (current US$) in Bosnia and Herzegovina in 2009 and the Value added (current US$) in Honduras in 2010?
Your answer should be very brief. -8.04e+08. What is the difference between the Value added (current US$) of Bosnia and Herzegovina in 2009 and the Value added (current US$) of Sweden in 2010?
Make the answer very short. -7.80e+1. What is the difference between the Value added (current US$) in France in 2009 and the Value added (current US$) in Honduras in 2010?
Give a very brief answer. 2.78e+11. What is the difference between the Value added (current US$) of France in 2009 and the Value added (current US$) of Sweden in 2010?
Your answer should be compact. 2.00e+11. What is the difference between the Value added (current US$) of Honduras in 2009 and the Value added (current US$) of Sweden in 2010?
Give a very brief answer. -7.74e+1. What is the difference between the Value added (current US$) of Bosnia and Herzegovina in 2009 and the Value added (current US$) of France in 2011?
Your answer should be compact. -2.91e+11. What is the difference between the Value added (current US$) of Bosnia and Herzegovina in 2009 and the Value added (current US$) of Honduras in 2011?
Offer a terse response. -1.23e+09. What is the difference between the Value added (current US$) of Bosnia and Herzegovina in 2009 and the Value added (current US$) of Sweden in 2011?
Your answer should be very brief. -8.88e+1. What is the difference between the Value added (current US$) of France in 2009 and the Value added (current US$) of Honduras in 2011?
Your response must be concise. 2.77e+11. What is the difference between the Value added (current US$) of France in 2009 and the Value added (current US$) of Sweden in 2011?
Give a very brief answer. 1.90e+11. What is the difference between the Value added (current US$) of Honduras in 2009 and the Value added (current US$) of Sweden in 2011?
Provide a short and direct response. -8.82e+1. What is the difference between the Value added (current US$) of Bosnia and Herzegovina in 2010 and the Value added (current US$) of France in 2011?
Give a very brief answer. -2.91e+11. What is the difference between the Value added (current US$) in Bosnia and Herzegovina in 2010 and the Value added (current US$) in Honduras in 2011?
Offer a very short reply. -1.21e+09. What is the difference between the Value added (current US$) of Bosnia and Herzegovina in 2010 and the Value added (current US$) of Sweden in 2011?
Provide a succinct answer. -8.88e+1. What is the difference between the Value added (current US$) in France in 2010 and the Value added (current US$) in Honduras in 2011?
Ensure brevity in your answer.  2.65e+11. What is the difference between the Value added (current US$) in France in 2010 and the Value added (current US$) in Sweden in 2011?
Provide a short and direct response. 1.78e+11. What is the difference between the Value added (current US$) of Honduras in 2010 and the Value added (current US$) of Sweden in 2011?
Your answer should be compact. -8.80e+1. What is the average Value added (current US$) of Bosnia and Herzegovina per year?
Keep it short and to the point. 1.58e+09. What is the average Value added (current US$) of France per year?
Your response must be concise. 2.82e+11. What is the average Value added (current US$) of Honduras per year?
Offer a terse response. 2.29e+09. What is the average Value added (current US$) of Sweden per year?
Provide a succinct answer. 7.84e+1. In the year 2004, what is the difference between the Value added (current US$) of Bosnia and Herzegovina and Value added (current US$) of France?
Keep it short and to the point. -2.62e+11. In the year 2004, what is the difference between the Value added (current US$) of Bosnia and Herzegovina and Value added (current US$) of Honduras?
Give a very brief answer. -7.41e+08. In the year 2004, what is the difference between the Value added (current US$) of Bosnia and Herzegovina and Value added (current US$) of Sweden?
Offer a terse response. -6.87e+1. In the year 2004, what is the difference between the Value added (current US$) in France and Value added (current US$) in Honduras?
Provide a succinct answer. 2.61e+11. In the year 2004, what is the difference between the Value added (current US$) of France and Value added (current US$) of Sweden?
Offer a very short reply. 1.93e+11. In the year 2004, what is the difference between the Value added (current US$) in Honduras and Value added (current US$) in Sweden?
Keep it short and to the point. -6.80e+1. In the year 2005, what is the difference between the Value added (current US$) of Bosnia and Herzegovina and Value added (current US$) of France?
Keep it short and to the point. -2.62e+11. In the year 2005, what is the difference between the Value added (current US$) of Bosnia and Herzegovina and Value added (current US$) of Honduras?
Provide a succinct answer. -7.66e+08. In the year 2005, what is the difference between the Value added (current US$) of Bosnia and Herzegovina and Value added (current US$) of Sweden?
Provide a succinct answer. -6.93e+1. In the year 2005, what is the difference between the Value added (current US$) in France and Value added (current US$) in Honduras?
Your response must be concise. 2.62e+11. In the year 2005, what is the difference between the Value added (current US$) in France and Value added (current US$) in Sweden?
Give a very brief answer. 1.93e+11. In the year 2005, what is the difference between the Value added (current US$) in Honduras and Value added (current US$) in Sweden?
Your answer should be very brief. -6.85e+1. In the year 2006, what is the difference between the Value added (current US$) in Bosnia and Herzegovina and Value added (current US$) in France?
Offer a terse response. -2.65e+11. In the year 2006, what is the difference between the Value added (current US$) of Bosnia and Herzegovina and Value added (current US$) of Honduras?
Your answer should be compact. -8.02e+08. In the year 2006, what is the difference between the Value added (current US$) of Bosnia and Herzegovina and Value added (current US$) of Sweden?
Your answer should be compact. -7.49e+1. In the year 2006, what is the difference between the Value added (current US$) in France and Value added (current US$) in Honduras?
Provide a short and direct response. 2.65e+11. In the year 2006, what is the difference between the Value added (current US$) of France and Value added (current US$) of Sweden?
Your answer should be compact. 1.90e+11. In the year 2006, what is the difference between the Value added (current US$) of Honduras and Value added (current US$) of Sweden?
Keep it short and to the point. -7.41e+1. In the year 2007, what is the difference between the Value added (current US$) in Bosnia and Herzegovina and Value added (current US$) in France?
Offer a terse response. -3.01e+11. In the year 2007, what is the difference between the Value added (current US$) in Bosnia and Herzegovina and Value added (current US$) in Honduras?
Offer a very short reply. -5.21e+08. In the year 2007, what is the difference between the Value added (current US$) in Bosnia and Herzegovina and Value added (current US$) in Sweden?
Your response must be concise. -8.67e+1. In the year 2007, what is the difference between the Value added (current US$) in France and Value added (current US$) in Honduras?
Your answer should be compact. 3.01e+11. In the year 2007, what is the difference between the Value added (current US$) of France and Value added (current US$) of Sweden?
Provide a succinct answer. 2.15e+11. In the year 2007, what is the difference between the Value added (current US$) of Honduras and Value added (current US$) of Sweden?
Provide a short and direct response. -8.62e+1. In the year 2008, what is the difference between the Value added (current US$) in Bosnia and Herzegovina and Value added (current US$) in France?
Ensure brevity in your answer.  -3.16e+11. In the year 2008, what is the difference between the Value added (current US$) of Bosnia and Herzegovina and Value added (current US$) of Honduras?
Offer a very short reply. -3.84e+08. In the year 2008, what is the difference between the Value added (current US$) of Bosnia and Herzegovina and Value added (current US$) of Sweden?
Give a very brief answer. -8.45e+1. In the year 2008, what is the difference between the Value added (current US$) of France and Value added (current US$) of Honduras?
Ensure brevity in your answer.  3.16e+11. In the year 2008, what is the difference between the Value added (current US$) of France and Value added (current US$) of Sweden?
Offer a very short reply. 2.32e+11. In the year 2008, what is the difference between the Value added (current US$) in Honduras and Value added (current US$) in Sweden?
Keep it short and to the point. -8.41e+1. In the year 2009, what is the difference between the Value added (current US$) of Bosnia and Herzegovina and Value added (current US$) of France?
Provide a short and direct response. -2.78e+11. In the year 2009, what is the difference between the Value added (current US$) of Bosnia and Herzegovina and Value added (current US$) of Honduras?
Keep it short and to the point. -6.11e+08. In the year 2009, what is the difference between the Value added (current US$) in Bosnia and Herzegovina and Value added (current US$) in Sweden?
Your answer should be compact. -6.35e+1. In the year 2009, what is the difference between the Value added (current US$) of France and Value added (current US$) of Honduras?
Keep it short and to the point. 2.78e+11. In the year 2009, what is the difference between the Value added (current US$) in France and Value added (current US$) in Sweden?
Your answer should be compact. 2.15e+11. In the year 2009, what is the difference between the Value added (current US$) of Honduras and Value added (current US$) of Sweden?
Provide a succinct answer. -6.29e+1. In the year 2010, what is the difference between the Value added (current US$) of Bosnia and Herzegovina and Value added (current US$) of France?
Provide a succinct answer. -2.67e+11. In the year 2010, what is the difference between the Value added (current US$) in Bosnia and Herzegovina and Value added (current US$) in Honduras?
Your response must be concise. -7.87e+08. In the year 2010, what is the difference between the Value added (current US$) of Bosnia and Herzegovina and Value added (current US$) of Sweden?
Your answer should be compact. -7.80e+1. In the year 2010, what is the difference between the Value added (current US$) of France and Value added (current US$) of Honduras?
Your response must be concise. 2.66e+11. In the year 2010, what is the difference between the Value added (current US$) in France and Value added (current US$) in Sweden?
Your answer should be compact. 1.89e+11. In the year 2010, what is the difference between the Value added (current US$) in Honduras and Value added (current US$) in Sweden?
Provide a short and direct response. -7.72e+1. In the year 2011, what is the difference between the Value added (current US$) in Bosnia and Herzegovina and Value added (current US$) in France?
Offer a terse response. -2.90e+11. In the year 2011, what is the difference between the Value added (current US$) of Bosnia and Herzegovina and Value added (current US$) of Honduras?
Your answer should be compact. -1.05e+09. In the year 2011, what is the difference between the Value added (current US$) of Bosnia and Herzegovina and Value added (current US$) of Sweden?
Your response must be concise. -8.86e+1. In the year 2011, what is the difference between the Value added (current US$) in France and Value added (current US$) in Honduras?
Your answer should be very brief. 2.89e+11. In the year 2011, what is the difference between the Value added (current US$) in France and Value added (current US$) in Sweden?
Ensure brevity in your answer.  2.02e+11. In the year 2011, what is the difference between the Value added (current US$) of Honduras and Value added (current US$) of Sweden?
Give a very brief answer. -8.76e+1. What is the ratio of the Value added (current US$) in Bosnia and Herzegovina in 2004 to that in 2005?
Keep it short and to the point. 0.87. What is the ratio of the Value added (current US$) of France in 2004 to that in 2005?
Ensure brevity in your answer.  1. What is the ratio of the Value added (current US$) of Honduras in 2004 to that in 2005?
Ensure brevity in your answer.  0.91. What is the ratio of the Value added (current US$) of Sweden in 2004 to that in 2005?
Make the answer very short. 0.99. What is the ratio of the Value added (current US$) of Bosnia and Herzegovina in 2004 to that in 2006?
Ensure brevity in your answer.  0.75. What is the ratio of the Value added (current US$) in France in 2004 to that in 2006?
Provide a succinct answer. 0.99. What is the ratio of the Value added (current US$) in Honduras in 2004 to that in 2006?
Keep it short and to the point. 0.82. What is the ratio of the Value added (current US$) of Sweden in 2004 to that in 2006?
Your answer should be compact. 0.91. What is the ratio of the Value added (current US$) in Bosnia and Herzegovina in 2004 to that in 2007?
Offer a very short reply. 0.56. What is the ratio of the Value added (current US$) of France in 2004 to that in 2007?
Ensure brevity in your answer.  0.87. What is the ratio of the Value added (current US$) of Honduras in 2004 to that in 2007?
Your response must be concise. 0.76. What is the ratio of the Value added (current US$) in Sweden in 2004 to that in 2007?
Ensure brevity in your answer.  0.79. What is the ratio of the Value added (current US$) in Bosnia and Herzegovina in 2004 to that in 2008?
Ensure brevity in your answer.  0.45. What is the ratio of the Value added (current US$) of France in 2004 to that in 2008?
Provide a succinct answer. 0.83. What is the ratio of the Value added (current US$) in Honduras in 2004 to that in 2008?
Make the answer very short. 0.68. What is the ratio of the Value added (current US$) of Sweden in 2004 to that in 2008?
Offer a terse response. 0.81. What is the ratio of the Value added (current US$) of Bosnia and Herzegovina in 2004 to that in 2009?
Provide a succinct answer. 0.52. What is the ratio of the Value added (current US$) of France in 2004 to that in 2009?
Your response must be concise. 0.94. What is the ratio of the Value added (current US$) in Honduras in 2004 to that in 2009?
Your response must be concise. 0.69. What is the ratio of the Value added (current US$) in Sweden in 2004 to that in 2009?
Make the answer very short. 1.07. What is the ratio of the Value added (current US$) of Bosnia and Herzegovina in 2004 to that in 2010?
Provide a short and direct response. 0.51. What is the ratio of the Value added (current US$) in Honduras in 2004 to that in 2010?
Provide a succinct answer. 0.64. What is the ratio of the Value added (current US$) of Sweden in 2004 to that in 2010?
Provide a succinct answer. 0.87. What is the ratio of the Value added (current US$) in Bosnia and Herzegovina in 2004 to that in 2011?
Your answer should be very brief. 0.47. What is the ratio of the Value added (current US$) of France in 2004 to that in 2011?
Ensure brevity in your answer.  0.9. What is the ratio of the Value added (current US$) in Honduras in 2004 to that in 2011?
Offer a very short reply. 0.55. What is the ratio of the Value added (current US$) of Sweden in 2004 to that in 2011?
Provide a short and direct response. 0.77. What is the ratio of the Value added (current US$) of Bosnia and Herzegovina in 2005 to that in 2006?
Give a very brief answer. 0.86. What is the ratio of the Value added (current US$) in France in 2005 to that in 2006?
Keep it short and to the point. 0.99. What is the ratio of the Value added (current US$) in Honduras in 2005 to that in 2006?
Offer a terse response. 0.9. What is the ratio of the Value added (current US$) in Sweden in 2005 to that in 2006?
Ensure brevity in your answer.  0.92. What is the ratio of the Value added (current US$) in Bosnia and Herzegovina in 2005 to that in 2007?
Your answer should be very brief. 0.64. What is the ratio of the Value added (current US$) of France in 2005 to that in 2007?
Make the answer very short. 0.87. What is the ratio of the Value added (current US$) of Honduras in 2005 to that in 2007?
Your answer should be compact. 0.84. What is the ratio of the Value added (current US$) in Sweden in 2005 to that in 2007?
Ensure brevity in your answer.  0.8. What is the ratio of the Value added (current US$) in Bosnia and Herzegovina in 2005 to that in 2008?
Provide a short and direct response. 0.52. What is the ratio of the Value added (current US$) in France in 2005 to that in 2008?
Give a very brief answer. 0.83. What is the ratio of the Value added (current US$) in Honduras in 2005 to that in 2008?
Give a very brief answer. 0.75. What is the ratio of the Value added (current US$) in Sweden in 2005 to that in 2008?
Give a very brief answer. 0.81. What is the ratio of the Value added (current US$) of Bosnia and Herzegovina in 2005 to that in 2009?
Offer a terse response. 0.59. What is the ratio of the Value added (current US$) in France in 2005 to that in 2009?
Ensure brevity in your answer.  0.94. What is the ratio of the Value added (current US$) of Honduras in 2005 to that in 2009?
Provide a succinct answer. 0.76. What is the ratio of the Value added (current US$) in Sweden in 2005 to that in 2009?
Your response must be concise. 1.08. What is the ratio of the Value added (current US$) in Bosnia and Herzegovina in 2005 to that in 2010?
Provide a short and direct response. 0.59. What is the ratio of the Value added (current US$) in France in 2005 to that in 2010?
Ensure brevity in your answer.  0.98. What is the ratio of the Value added (current US$) of Honduras in 2005 to that in 2010?
Offer a terse response. 0.7. What is the ratio of the Value added (current US$) in Sweden in 2005 to that in 2010?
Provide a short and direct response. 0.88. What is the ratio of the Value added (current US$) in Bosnia and Herzegovina in 2005 to that in 2011?
Give a very brief answer. 0.54. What is the ratio of the Value added (current US$) in France in 2005 to that in 2011?
Ensure brevity in your answer.  0.9. What is the ratio of the Value added (current US$) in Honduras in 2005 to that in 2011?
Provide a short and direct response. 0.61. What is the ratio of the Value added (current US$) in Sweden in 2005 to that in 2011?
Provide a short and direct response. 0.78. What is the ratio of the Value added (current US$) of Bosnia and Herzegovina in 2006 to that in 2007?
Ensure brevity in your answer.  0.75. What is the ratio of the Value added (current US$) of France in 2006 to that in 2007?
Your response must be concise. 0.88. What is the ratio of the Value added (current US$) in Sweden in 2006 to that in 2007?
Your answer should be very brief. 0.86. What is the ratio of the Value added (current US$) in Bosnia and Herzegovina in 2006 to that in 2008?
Your response must be concise. 0.61. What is the ratio of the Value added (current US$) of France in 2006 to that in 2008?
Your response must be concise. 0.84. What is the ratio of the Value added (current US$) of Honduras in 2006 to that in 2008?
Offer a terse response. 0.84. What is the ratio of the Value added (current US$) of Sweden in 2006 to that in 2008?
Make the answer very short. 0.88. What is the ratio of the Value added (current US$) in Bosnia and Herzegovina in 2006 to that in 2009?
Make the answer very short. 0.69. What is the ratio of the Value added (current US$) of France in 2006 to that in 2009?
Your response must be concise. 0.95. What is the ratio of the Value added (current US$) in Honduras in 2006 to that in 2009?
Provide a short and direct response. 0.85. What is the ratio of the Value added (current US$) of Sweden in 2006 to that in 2009?
Your answer should be compact. 1.17. What is the ratio of the Value added (current US$) of Bosnia and Herzegovina in 2006 to that in 2010?
Provide a short and direct response. 0.68. What is the ratio of the Value added (current US$) of Honduras in 2006 to that in 2010?
Provide a succinct answer. 0.79. What is the ratio of the Value added (current US$) of Sweden in 2006 to that in 2010?
Your answer should be compact. 0.95. What is the ratio of the Value added (current US$) of Bosnia and Herzegovina in 2006 to that in 2011?
Give a very brief answer. 0.63. What is the ratio of the Value added (current US$) of France in 2006 to that in 2011?
Offer a very short reply. 0.91. What is the ratio of the Value added (current US$) in Honduras in 2006 to that in 2011?
Offer a very short reply. 0.68. What is the ratio of the Value added (current US$) of Sweden in 2006 to that in 2011?
Your answer should be compact. 0.84. What is the ratio of the Value added (current US$) in Bosnia and Herzegovina in 2007 to that in 2008?
Give a very brief answer. 0.81. What is the ratio of the Value added (current US$) of France in 2007 to that in 2008?
Keep it short and to the point. 0.95. What is the ratio of the Value added (current US$) of Honduras in 2007 to that in 2008?
Give a very brief answer. 0.9. What is the ratio of the Value added (current US$) of Sweden in 2007 to that in 2008?
Your response must be concise. 1.02. What is the ratio of the Value added (current US$) in Bosnia and Herzegovina in 2007 to that in 2009?
Provide a short and direct response. 0.93. What is the ratio of the Value added (current US$) in France in 2007 to that in 2009?
Your answer should be compact. 1.08. What is the ratio of the Value added (current US$) of Honduras in 2007 to that in 2009?
Make the answer very short. 0.91. What is the ratio of the Value added (current US$) in Sweden in 2007 to that in 2009?
Your answer should be very brief. 1.35. What is the ratio of the Value added (current US$) in Bosnia and Herzegovina in 2007 to that in 2010?
Your answer should be very brief. 0.92. What is the ratio of the Value added (current US$) of France in 2007 to that in 2010?
Offer a terse response. 1.13. What is the ratio of the Value added (current US$) of Honduras in 2007 to that in 2010?
Provide a short and direct response. 0.84. What is the ratio of the Value added (current US$) of Sweden in 2007 to that in 2010?
Your answer should be very brief. 1.11. What is the ratio of the Value added (current US$) in Bosnia and Herzegovina in 2007 to that in 2011?
Make the answer very short. 0.84. What is the ratio of the Value added (current US$) in France in 2007 to that in 2011?
Make the answer very short. 1.04. What is the ratio of the Value added (current US$) in Honduras in 2007 to that in 2011?
Make the answer very short. 0.72. What is the ratio of the Value added (current US$) in Sweden in 2007 to that in 2011?
Ensure brevity in your answer.  0.97. What is the ratio of the Value added (current US$) in Bosnia and Herzegovina in 2008 to that in 2009?
Keep it short and to the point. 1.14. What is the ratio of the Value added (current US$) of France in 2008 to that in 2009?
Offer a terse response. 1.14. What is the ratio of the Value added (current US$) in Honduras in 2008 to that in 2009?
Give a very brief answer. 1.01. What is the ratio of the Value added (current US$) of Sweden in 2008 to that in 2009?
Make the answer very short. 1.33. What is the ratio of the Value added (current US$) of Bosnia and Herzegovina in 2008 to that in 2010?
Your response must be concise. 1.13. What is the ratio of the Value added (current US$) of France in 2008 to that in 2010?
Your response must be concise. 1.19. What is the ratio of the Value added (current US$) of Honduras in 2008 to that in 2010?
Make the answer very short. 0.94. What is the ratio of the Value added (current US$) of Sweden in 2008 to that in 2010?
Make the answer very short. 1.08. What is the ratio of the Value added (current US$) in Bosnia and Herzegovina in 2008 to that in 2011?
Provide a succinct answer. 1.04. What is the ratio of the Value added (current US$) of France in 2008 to that in 2011?
Give a very brief answer. 1.09. What is the ratio of the Value added (current US$) of Honduras in 2008 to that in 2011?
Provide a succinct answer. 0.81. What is the ratio of the Value added (current US$) in Sweden in 2008 to that in 2011?
Your answer should be very brief. 0.95. What is the ratio of the Value added (current US$) of Bosnia and Herzegovina in 2009 to that in 2010?
Your response must be concise. 0.99. What is the ratio of the Value added (current US$) in France in 2009 to that in 2010?
Provide a succinct answer. 1.04. What is the ratio of the Value added (current US$) of Honduras in 2009 to that in 2010?
Offer a very short reply. 0.93. What is the ratio of the Value added (current US$) in Sweden in 2009 to that in 2010?
Keep it short and to the point. 0.82. What is the ratio of the Value added (current US$) in Bosnia and Herzegovina in 2009 to that in 2011?
Offer a very short reply. 0.91. What is the ratio of the Value added (current US$) in France in 2009 to that in 2011?
Offer a very short reply. 0.96. What is the ratio of the Value added (current US$) in Honduras in 2009 to that in 2011?
Provide a succinct answer. 0.8. What is the ratio of the Value added (current US$) in Sweden in 2009 to that in 2011?
Give a very brief answer. 0.72. What is the ratio of the Value added (current US$) of Bosnia and Herzegovina in 2010 to that in 2011?
Your response must be concise. 0.92. What is the ratio of the Value added (current US$) in France in 2010 to that in 2011?
Offer a terse response. 0.92. What is the ratio of the Value added (current US$) in Honduras in 2010 to that in 2011?
Provide a short and direct response. 0.86. What is the ratio of the Value added (current US$) in Sweden in 2010 to that in 2011?
Ensure brevity in your answer.  0.88. What is the difference between the highest and the second highest Value added (current US$) in Bosnia and Herzegovina?
Provide a succinct answer. 7.37e+07. What is the difference between the highest and the second highest Value added (current US$) in France?
Provide a short and direct response. 1.50e+1. What is the difference between the highest and the second highest Value added (current US$) of Honduras?
Your answer should be compact. 4.26e+08. What is the difference between the highest and the second highest Value added (current US$) in Sweden?
Make the answer very short. 2.28e+09. What is the difference between the highest and the lowest Value added (current US$) of Bosnia and Herzegovina?
Provide a short and direct response. 1.13e+09. What is the difference between the highest and the lowest Value added (current US$) of France?
Keep it short and to the point. 5.52e+1. What is the difference between the highest and the lowest Value added (current US$) in Honduras?
Offer a terse response. 1.36e+09. What is the difference between the highest and the lowest Value added (current US$) of Sweden?
Make the answer very short. 2.53e+1. 